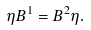Convert formula to latex. <formula><loc_0><loc_0><loc_500><loc_500>\eta B ^ { 1 } = B ^ { 2 } \eta .</formula> 